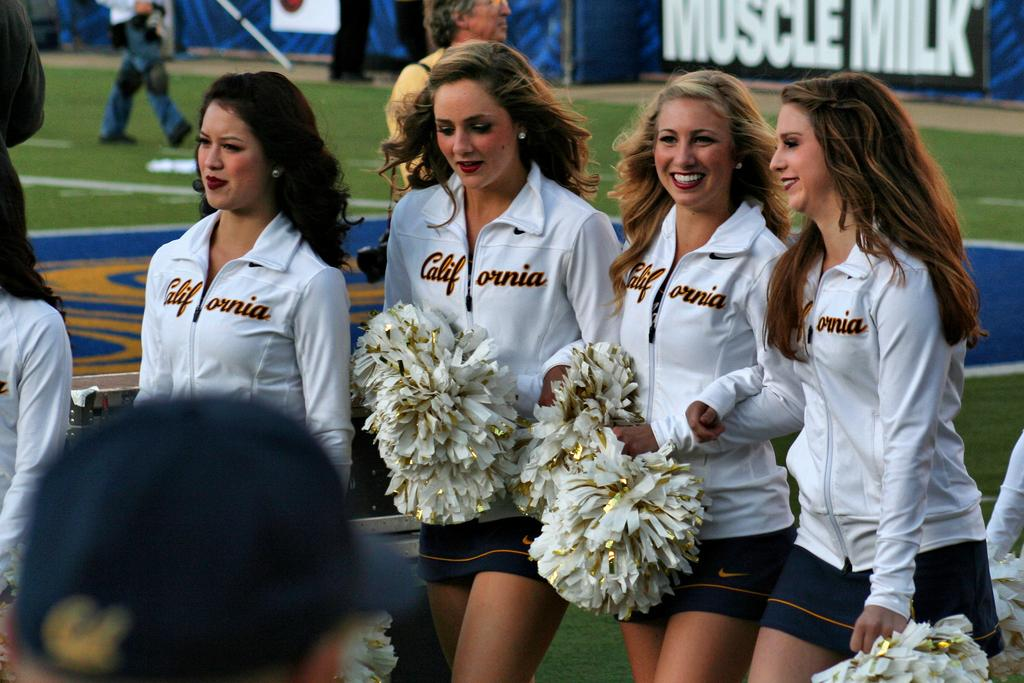<image>
Offer a succinct explanation of the picture presented. The cheerleaders are wearing white tops from California 